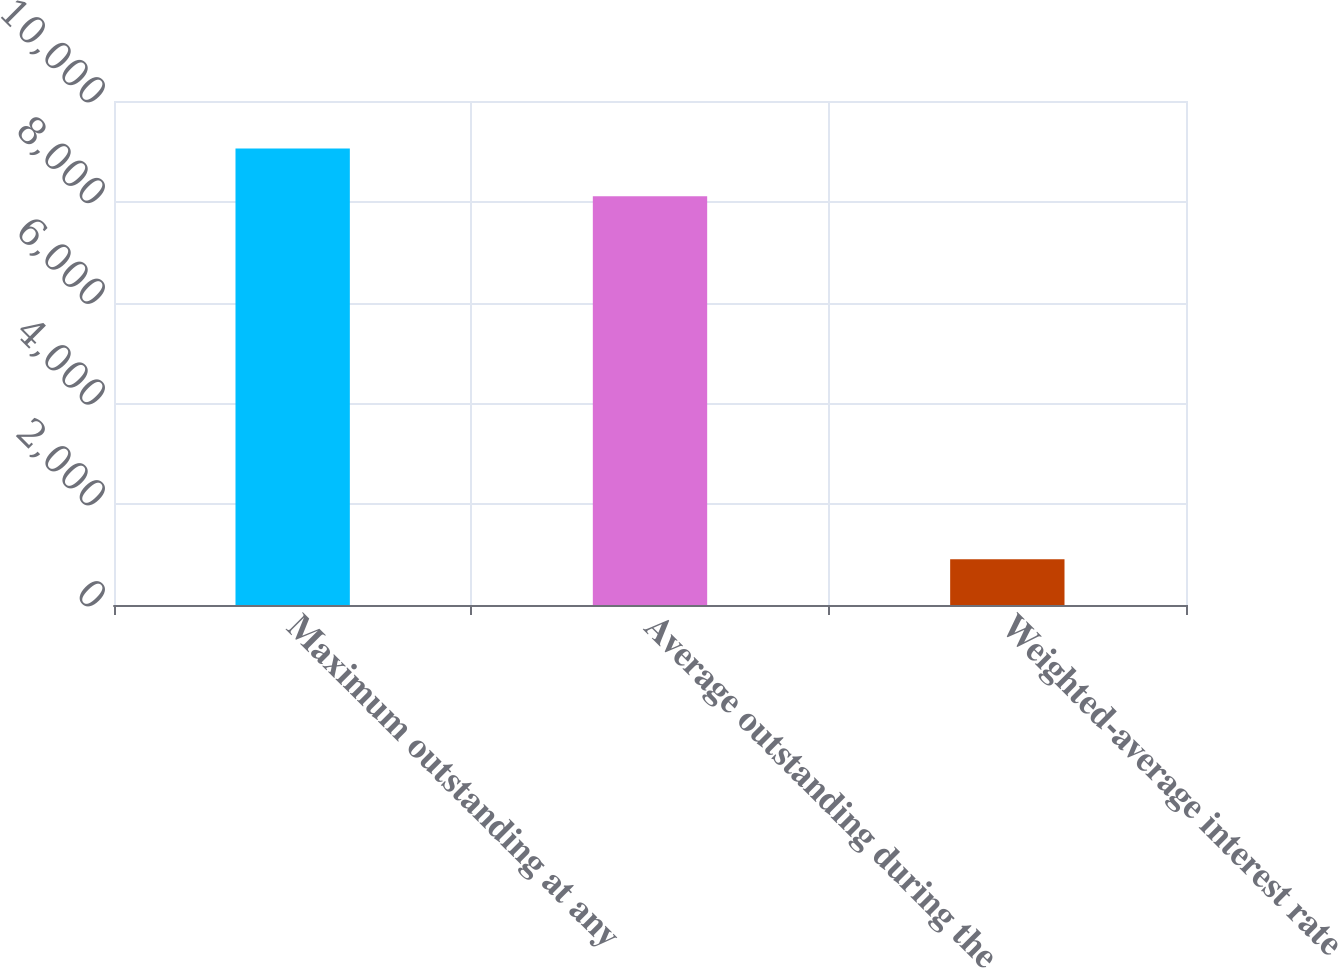<chart> <loc_0><loc_0><loc_500><loc_500><bar_chart><fcel>Maximum outstanding at any<fcel>Average outstanding during the<fcel>Weighted-average interest rate<nl><fcel>9058<fcel>8108<fcel>905.84<nl></chart> 